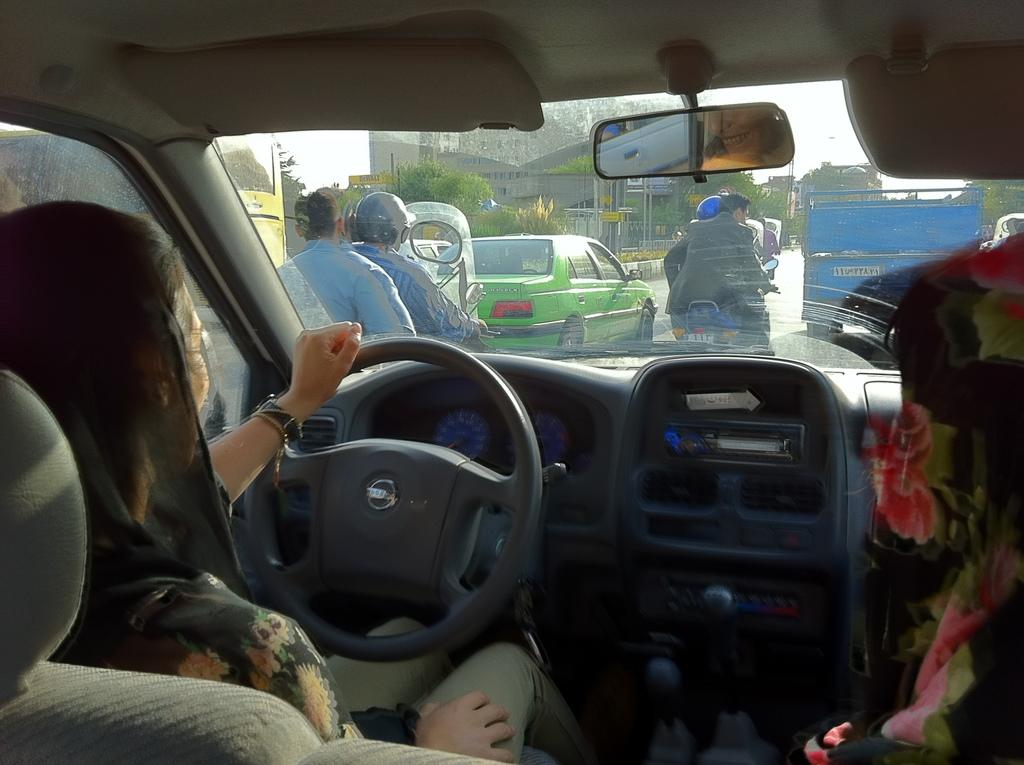What is the woman in the image doing? The woman is driving a car in the image. What other types of vehicles can be seen in the image? There are motorcycles and at least one other car in the image. Can you describe the road conditions in the image? There is a vehicle on the road in the image. What type of structures are visible in the image? There are buildings visible in the image. What type of vegetation is present in the image? There are trees in the image. What type of low-flying aircraft can be seen in the image? There is no low-flying aircraft present in the image. 